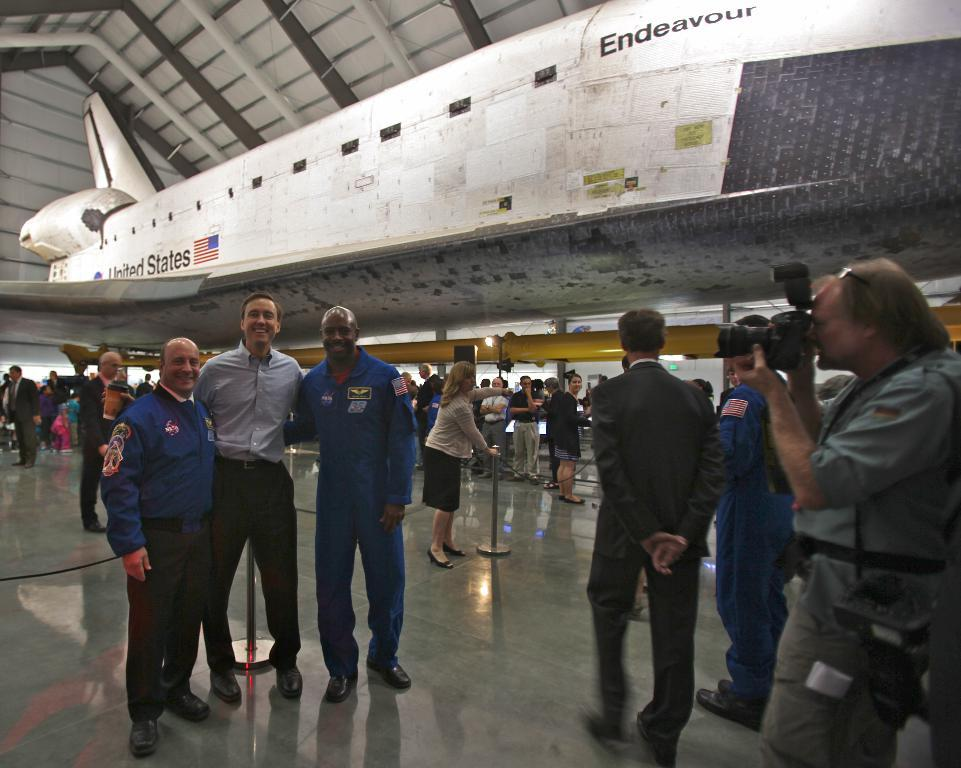Provide a one-sentence caption for the provided image. People pose in front of the United States space shuttle Endeavor. 